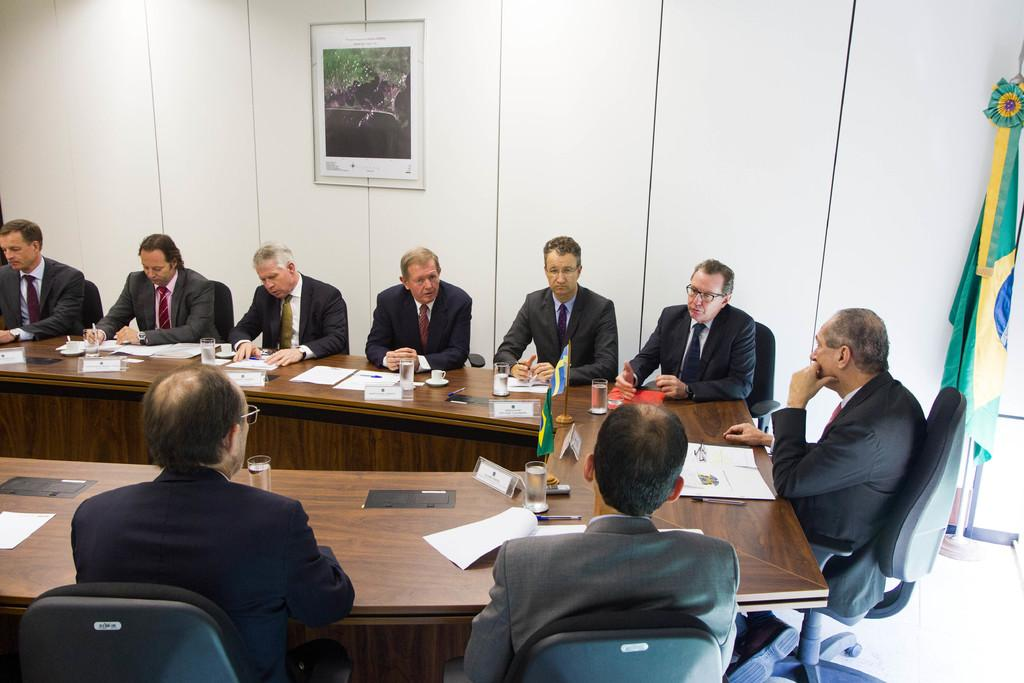How many people are in the image? There is a group of persons in the image. What are the persons wearing? The persons are wearing suits. Where are the persons seated in relation to the table? The persons are seated in front of a table. What items can be seen on the table? There are papers, a glass of water, and two flags on the table. What time of day is represented by the hour on the table? There is no hour present on the table in the image. What word is written on the papers on the table? We cannot determine the specific word written on the papers from the image. 